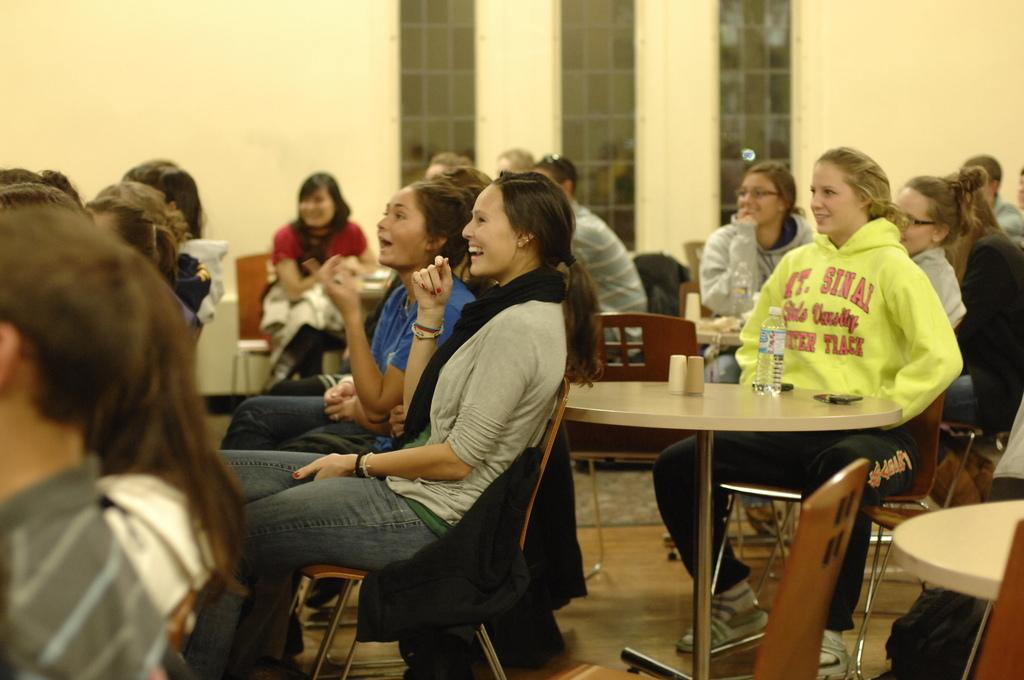How many people are in the image? There is a group of people in the image. What are the people doing in the image? The people are sitting on chairs. Where are the chairs located in relation to the table? The chairs are in front of a table. What can be seen in the background of the image? There is a wall and windows in the background of the image. Where was the image taken? The image was taken in a hall. What type of account does the person on the edge of the image have? There is no person on the edge of the image, and no mention of an account in the provided facts. 